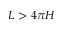Convert formula to latex. <formula><loc_0><loc_0><loc_500><loc_500>L > 4 \pi H</formula> 